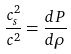Convert formula to latex. <formula><loc_0><loc_0><loc_500><loc_500>\frac { c ^ { 2 } _ { s } } { c ^ { 2 } } = \frac { d P } { d \rho }</formula> 